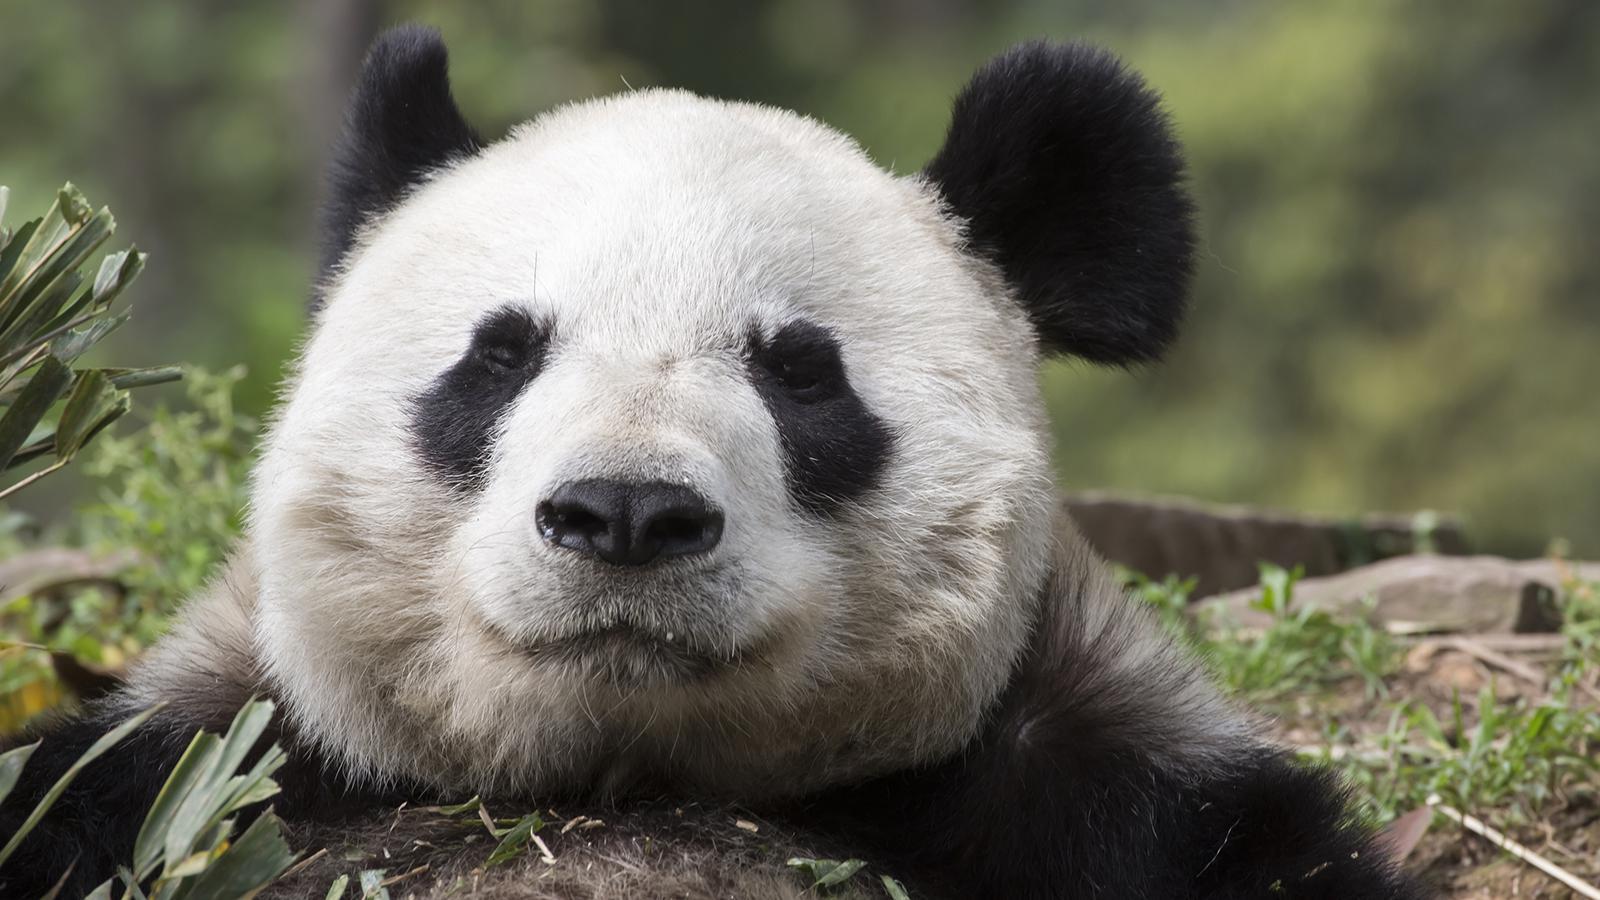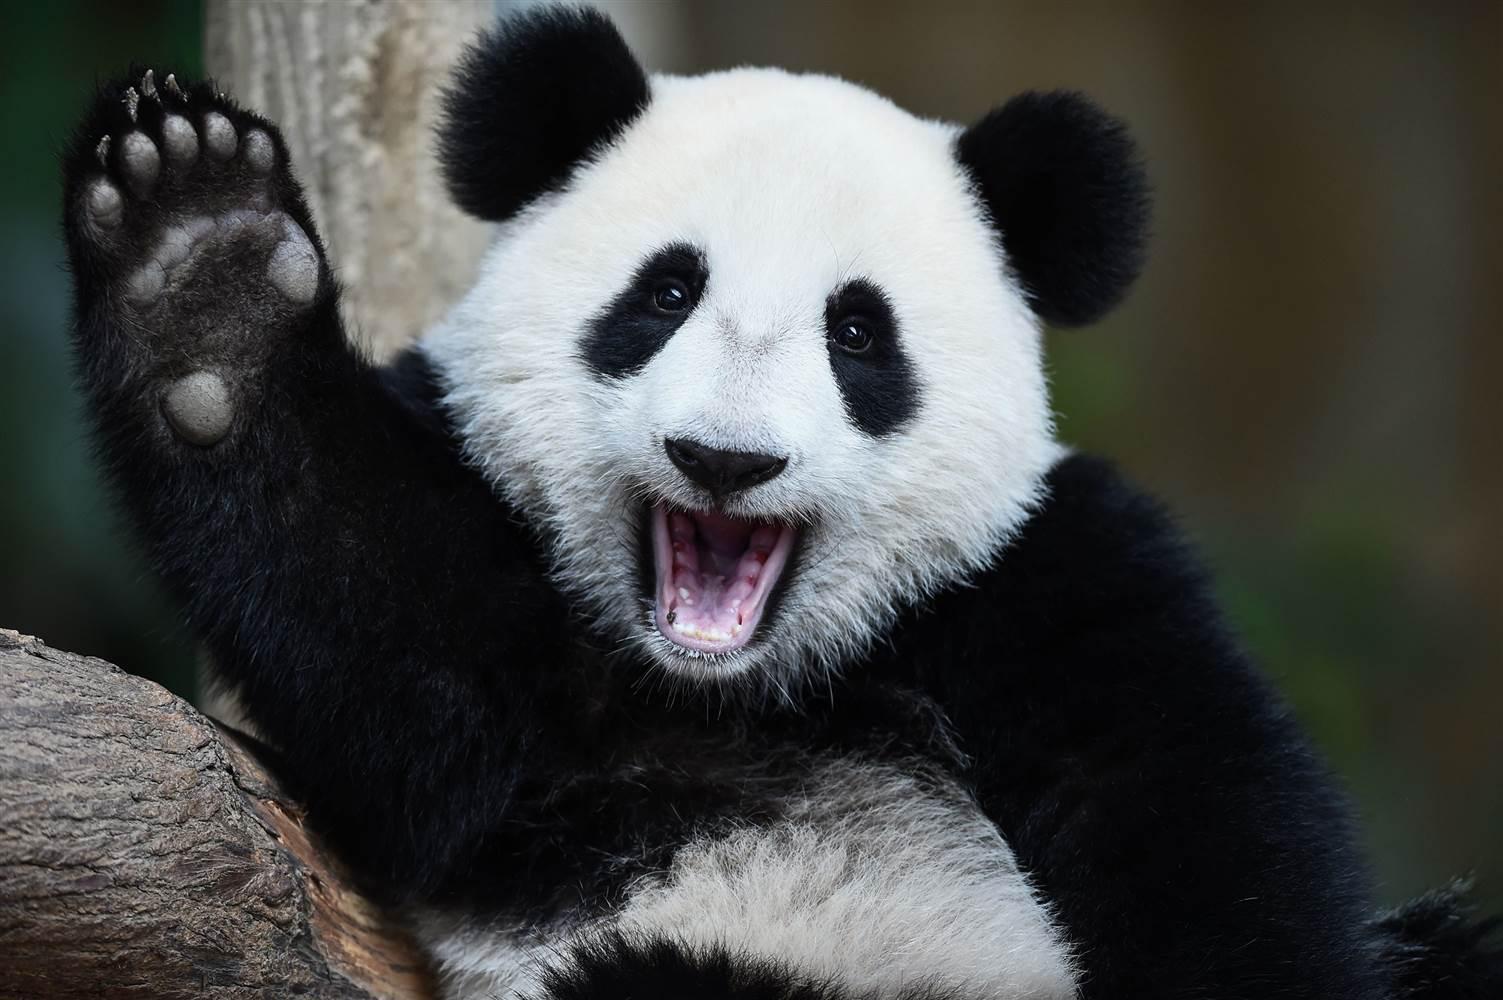The first image is the image on the left, the second image is the image on the right. Assess this claim about the two images: "At least one of the pandas is holding onto a tree branch.". Correct or not? Answer yes or no. No. The first image is the image on the left, the second image is the image on the right. Assess this claim about the two images: "An image shows a panda with paws over a horizontal  tree limb.". Correct or not? Answer yes or no. No. 